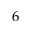Convert formula to latex. <formula><loc_0><loc_0><loc_500><loc_500>6</formula> 